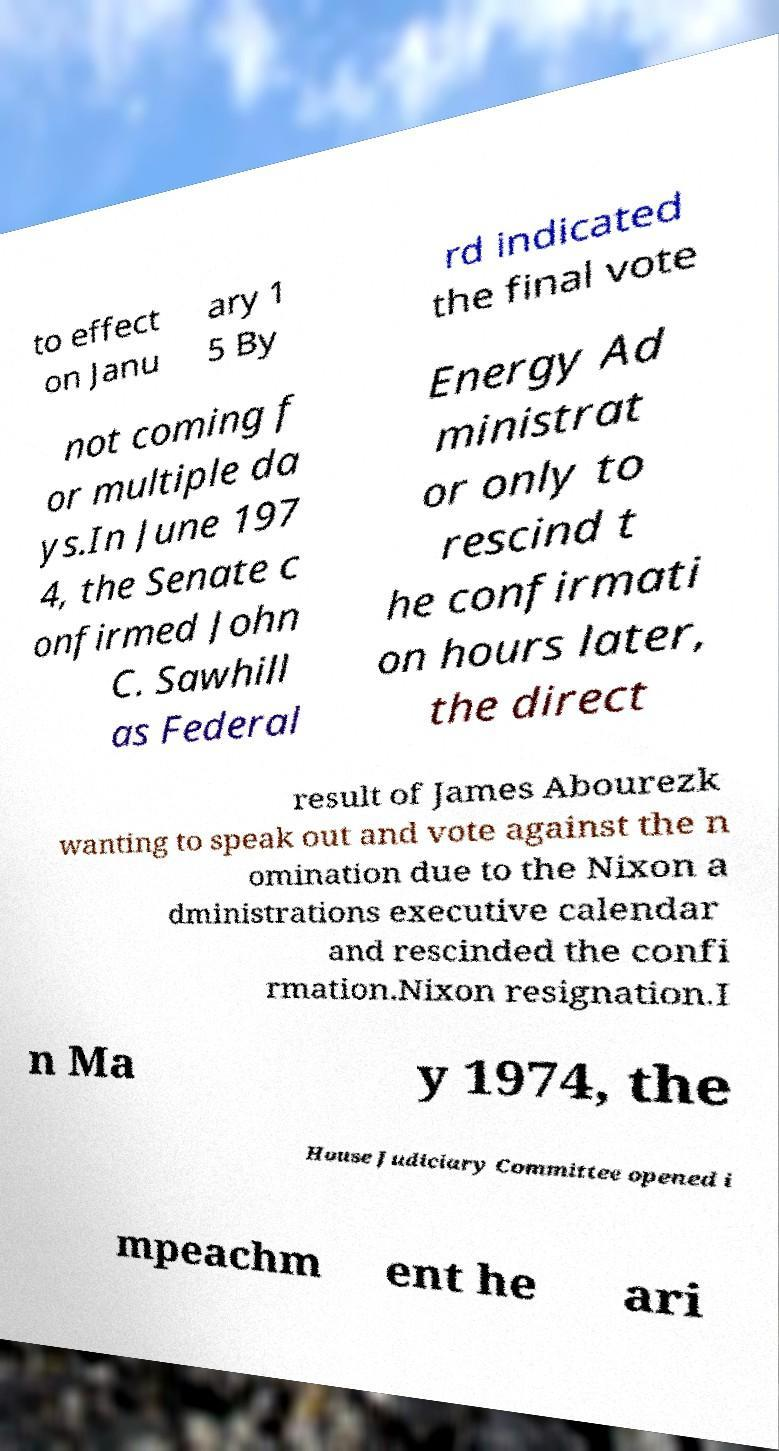Could you extract and type out the text from this image? to effect on Janu ary 1 5 By rd indicated the final vote not coming f or multiple da ys.In June 197 4, the Senate c onfirmed John C. Sawhill as Federal Energy Ad ministrat or only to rescind t he confirmati on hours later, the direct result of James Abourezk wanting to speak out and vote against the n omination due to the Nixon a dministrations executive calendar and rescinded the confi rmation.Nixon resignation.I n Ma y 1974, the House Judiciary Committee opened i mpeachm ent he ari 